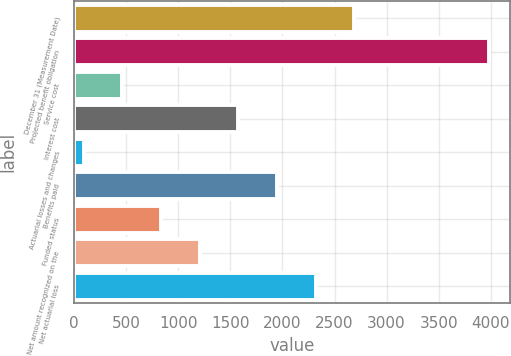Convert chart to OTSL. <chart><loc_0><loc_0><loc_500><loc_500><bar_chart><fcel>December 31 (Measurement Date)<fcel>Projected benefit obligation<fcel>Service cost<fcel>Interest cost<fcel>Actuarial losses and changes<fcel>Benefits paid<fcel>Funded status<fcel>Net amount recognized on the<fcel>Net actuarial loss<nl><fcel>2689.7<fcel>3982.1<fcel>463.1<fcel>1576.4<fcel>92<fcel>1947.5<fcel>834.2<fcel>1205.3<fcel>2318.6<nl></chart> 